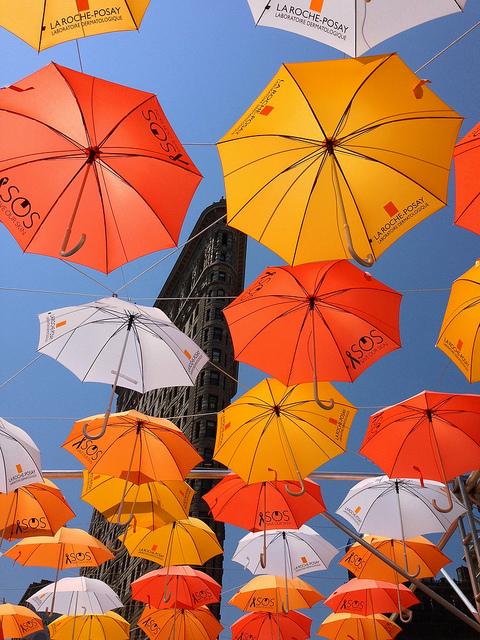What is hanging?
Be succinct. Umbrellas. How many umbrellas in the pictures?
Give a very brief answer. 27. Is the sky blue?
Concise answer only. Yes. 